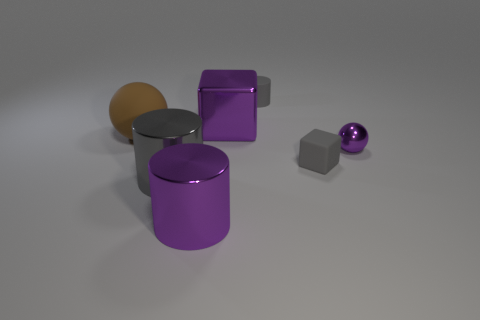What could be the potential use for these objects if they were real? If these objects were real, the cylinders could be decorative containers or modern furniture pieces, perhaps stools or side tables. The cube might serve as a storage cube or minimalist decor item, and the small sphere could be an artistic ornament, adding a pop of color and shape contrast in a contemporary living space. 